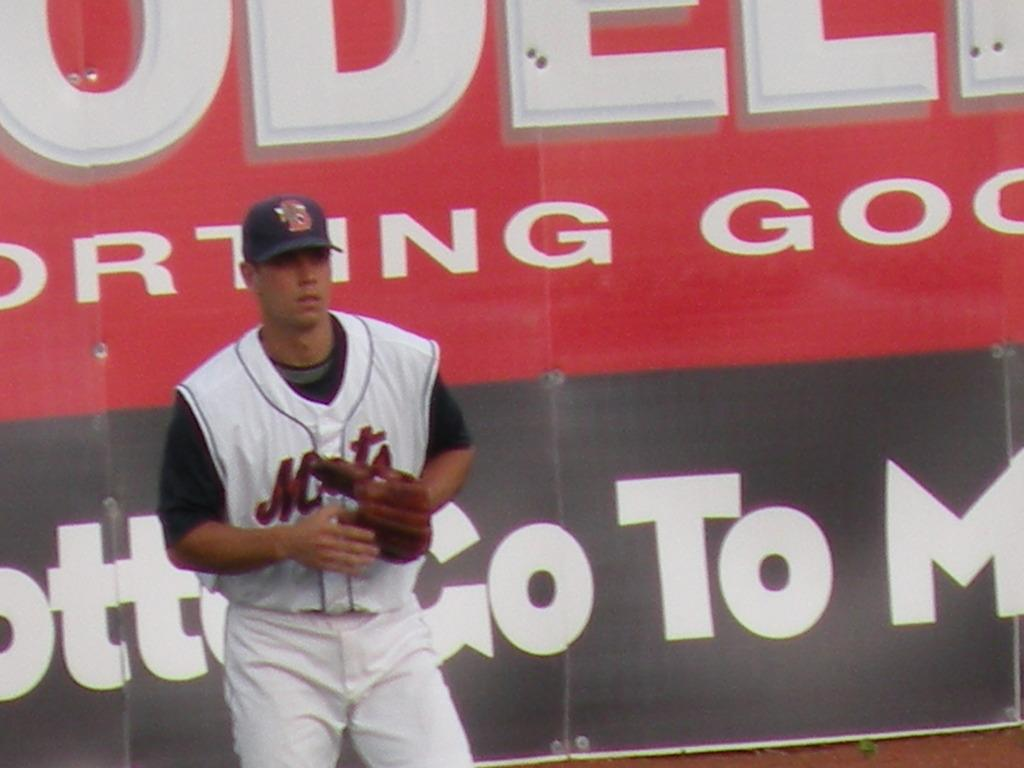<image>
Create a compact narrative representing the image presented. A Mets players standing in front of a big Modell's sign. 